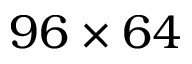<formula> <loc_0><loc_0><loc_500><loc_500>9 6 \times 6 4</formula> 